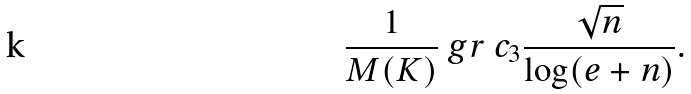<formula> <loc_0><loc_0><loc_500><loc_500>\frac { 1 } { M ( K ) } \ g r \ c _ { 3 } \frac { \sqrt { n } } { \log ( e + n ) } .</formula> 